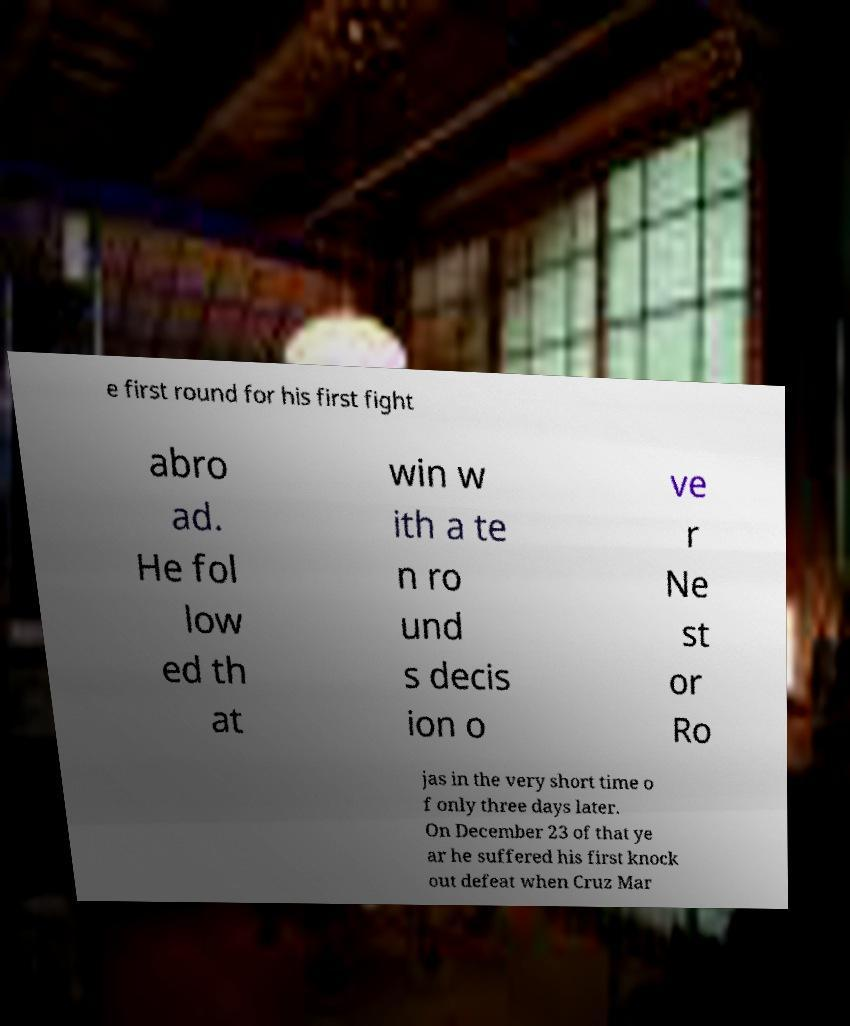Please read and relay the text visible in this image. What does it say? e first round for his first fight abro ad. He fol low ed th at win w ith a te n ro und s decis ion o ve r Ne st or Ro jas in the very short time o f only three days later. On December 23 of that ye ar he suffered his first knock out defeat when Cruz Mar 